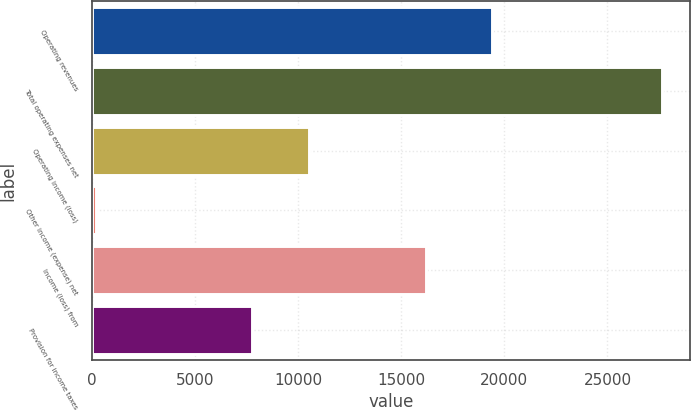Convert chart. <chart><loc_0><loc_0><loc_500><loc_500><bar_chart><fcel>Operating revenues<fcel>Total operating expenses net<fcel>Operating income (loss)<fcel>Other income (expense) net<fcel>Income (loss) from<fcel>Provision for income taxes<nl><fcel>19377<fcel>27630<fcel>10505.2<fcel>168<fcel>16180<fcel>7759<nl></chart> 